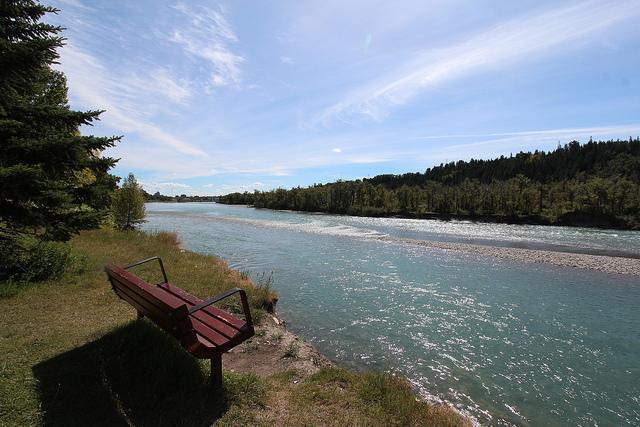How many people are at the bench?
Give a very brief answer. 0. 